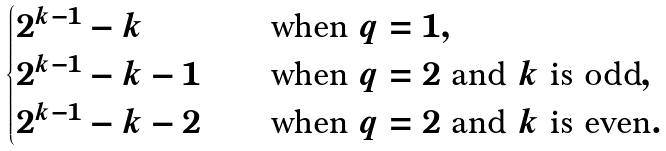Convert formula to latex. <formula><loc_0><loc_0><loc_500><loc_500>\begin{cases} 2 ^ { k - 1 } - k \quad & \text {when $q=1$} , \\ 2 ^ { k - 1 } - k - 1 \quad & \text {when $q=2$ and $k$ is odd} , \\ 2 ^ { k - 1 } - k - 2 \quad & \text {when $q=2$ and $k$ is even} . \end{cases}</formula> 